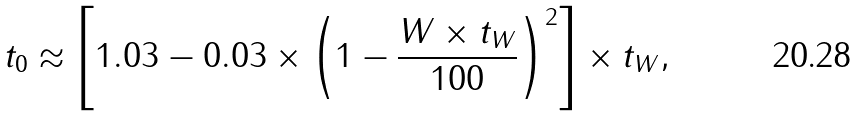Convert formula to latex. <formula><loc_0><loc_0><loc_500><loc_500>t _ { 0 } \approx \left [ 1 . 0 3 - 0 . 0 3 \times \left ( 1 - \frac { W \times t _ { W } } { 1 0 0 } \right ) ^ { 2 } \right ] \times t _ { W } ,</formula> 